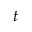Convert formula to latex. <formula><loc_0><loc_0><loc_500><loc_500>t</formula> 